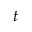Convert formula to latex. <formula><loc_0><loc_0><loc_500><loc_500>t</formula> 